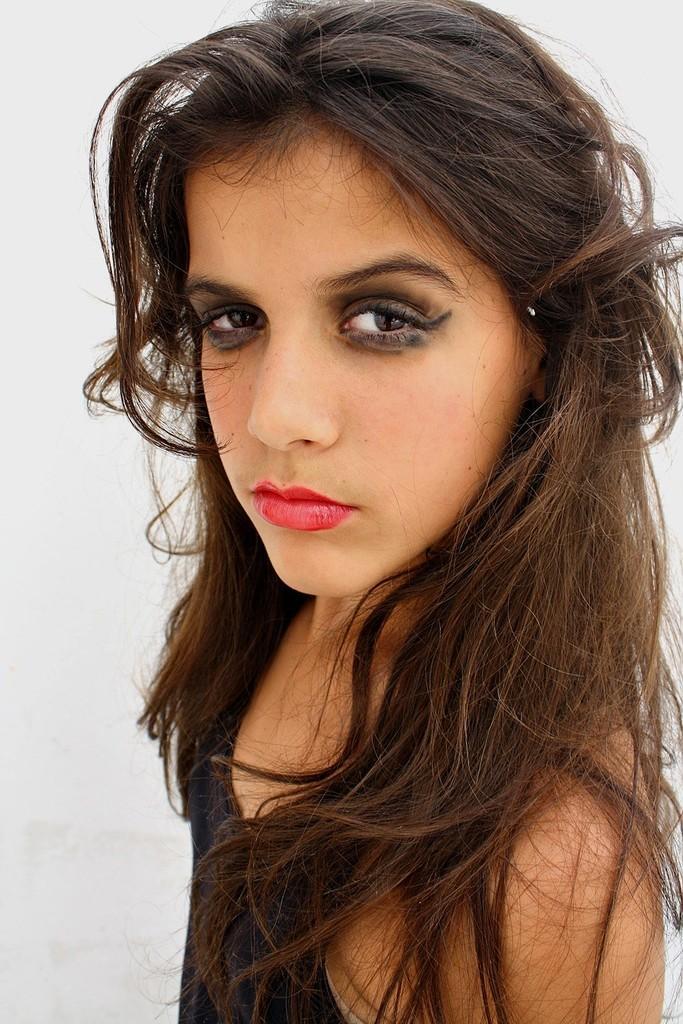In one or two sentences, can you explain what this image depicts? In the middle of the image there is a girl. In this image the background is white in color. 